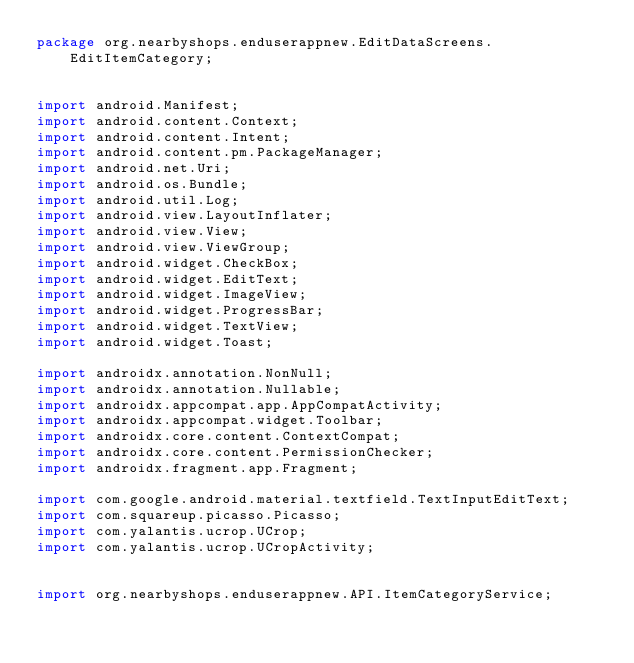Convert code to text. <code><loc_0><loc_0><loc_500><loc_500><_Java_>package org.nearbyshops.enduserappnew.EditDataScreens.EditItemCategory;


import android.Manifest;
import android.content.Context;
import android.content.Intent;
import android.content.pm.PackageManager;
import android.net.Uri;
import android.os.Bundle;
import android.util.Log;
import android.view.LayoutInflater;
import android.view.View;
import android.view.ViewGroup;
import android.widget.CheckBox;
import android.widget.EditText;
import android.widget.ImageView;
import android.widget.ProgressBar;
import android.widget.TextView;
import android.widget.Toast;

import androidx.annotation.NonNull;
import androidx.annotation.Nullable;
import androidx.appcompat.app.AppCompatActivity;
import androidx.appcompat.widget.Toolbar;
import androidx.core.content.ContextCompat;
import androidx.core.content.PermissionChecker;
import androidx.fragment.app.Fragment;

import com.google.android.material.textfield.TextInputEditText;
import com.squareup.picasso.Picasso;
import com.yalantis.ucrop.UCrop;
import com.yalantis.ucrop.UCropActivity;


import org.nearbyshops.enduserappnew.API.ItemCategoryService;</code> 